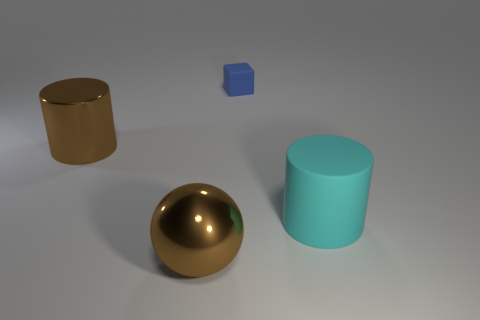Add 2 cyan matte things. How many objects exist? 6 Subtract all brown cylinders. How many cylinders are left? 1 Subtract all spheres. How many objects are left? 3 Add 3 small green balls. How many small green balls exist? 3 Subtract 0 purple cylinders. How many objects are left? 4 Subtract all blue cubes. Subtract all yellow things. How many objects are left? 3 Add 4 large brown objects. How many large brown objects are left? 6 